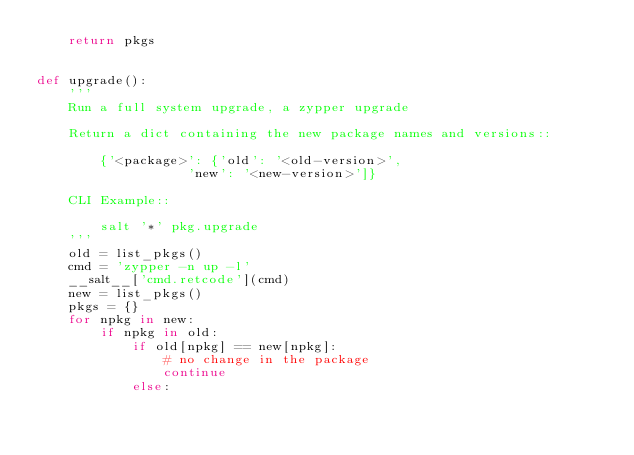Convert code to text. <code><loc_0><loc_0><loc_500><loc_500><_Python_>    return pkgs


def upgrade():
    '''
    Run a full system upgrade, a zypper upgrade

    Return a dict containing the new package names and versions::

        {'<package>': {'old': '<old-version>',
                   'new': '<new-version>']}

    CLI Example::

        salt '*' pkg.upgrade
    '''
    old = list_pkgs()
    cmd = 'zypper -n up -l'
    __salt__['cmd.retcode'](cmd)
    new = list_pkgs()
    pkgs = {}
    for npkg in new:
        if npkg in old:
            if old[npkg] == new[npkg]:
                # no change in the package
                continue
            else:</code> 